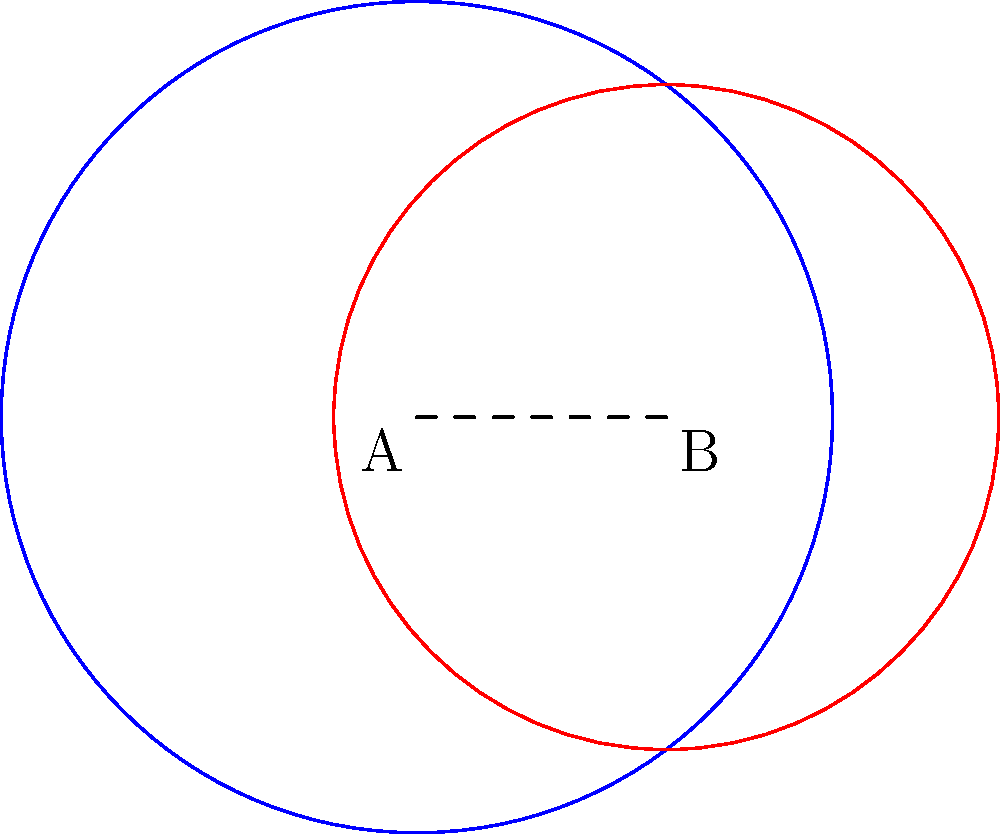Two circular fields of vision are represented by the blue and red circles in the diagram. Circle A has a radius of 5 units, and circle B has a radius of 4 units. The centers of the circles are 3 units apart. Calculate the area of the overlapping region between these two fields of vision. Round your answer to two decimal places. To find the area of overlap between two circles, we can use the formula for the area of intersection:

1) First, calculate the distance $d$ between the centers:
   $d = 3$ (given in the question)

2) Use the formula for the area of intersection:
   $$A = r_1^2 \arccos(\frac{d^2 + r_1^2 - r_2^2}{2dr_1}) + r_2^2 \arccos(\frac{d^2 + r_2^2 - r_1^2}{2dr_2}) - \frac{1}{2}\sqrt{(-d+r_1+r_2)(d+r_1-r_2)(d-r_1+r_2)(d+r_1+r_2)}$$

3) Substitute the values:
   $r_1 = 5$, $r_2 = 4$, $d = 3$

4) Calculate each part:
   $$5^2 \arccos(\frac{3^2 + 5^2 - 4^2}{2 \cdot 3 \cdot 5}) + 4^2 \arccos(\frac{3^2 + 4^2 - 5^2}{2 \cdot 3 \cdot 4}) - \frac{1}{2}\sqrt{(-3+5+4)(3+5-4)(3-5+4)(3+5+4)}$$

5) Simplify and calculate:
   $$25 \arccos(0.7833) + 16 \arccos(-0.0417) - \frac{1}{2}\sqrt{6 \cdot 4 \cdot 2 \cdot 12}$$
   $$\approx 25 \cdot 0.6735 + 16 \cdot 1.6124 - \frac{1}{2}\sqrt{576}$$
   $$\approx 16.8375 + 25.7984 - 12$$
   $$\approx 30.6359$$

6) Round to two decimal places:
   $30.64$

Therefore, the area of the overlapping region is approximately 30.64 square units.
Answer: 30.64 square units 